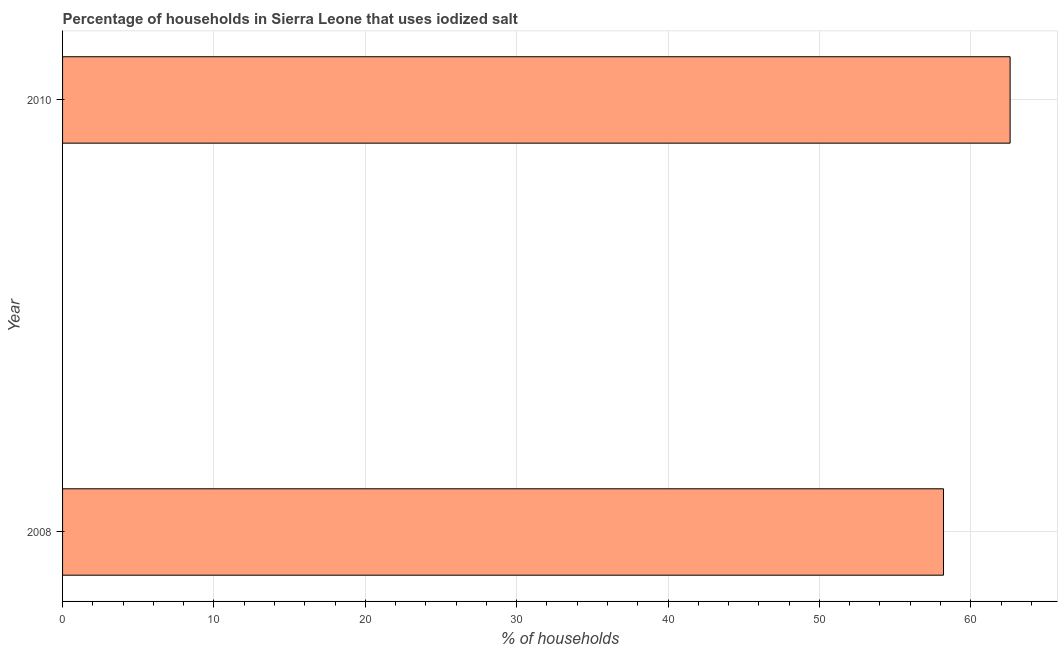What is the title of the graph?
Offer a very short reply. Percentage of households in Sierra Leone that uses iodized salt. What is the label or title of the X-axis?
Your answer should be compact. % of households. What is the label or title of the Y-axis?
Provide a succinct answer. Year. What is the percentage of households where iodized salt is consumed in 2010?
Provide a succinct answer. 62.6. Across all years, what is the maximum percentage of households where iodized salt is consumed?
Your answer should be compact. 62.6. Across all years, what is the minimum percentage of households where iodized salt is consumed?
Offer a terse response. 58.2. In which year was the percentage of households where iodized salt is consumed maximum?
Your answer should be very brief. 2010. In which year was the percentage of households where iodized salt is consumed minimum?
Your answer should be very brief. 2008. What is the sum of the percentage of households where iodized salt is consumed?
Give a very brief answer. 120.8. What is the average percentage of households where iodized salt is consumed per year?
Your answer should be compact. 60.4. What is the median percentage of households where iodized salt is consumed?
Offer a very short reply. 60.4. In how many years, is the percentage of households where iodized salt is consumed greater than 44 %?
Give a very brief answer. 2. Do a majority of the years between 2008 and 2010 (inclusive) have percentage of households where iodized salt is consumed greater than 24 %?
Offer a terse response. Yes. What is the difference between two consecutive major ticks on the X-axis?
Provide a succinct answer. 10. Are the values on the major ticks of X-axis written in scientific E-notation?
Offer a very short reply. No. What is the % of households in 2008?
Offer a terse response. 58.2. What is the % of households in 2010?
Your response must be concise. 62.6. What is the ratio of the % of households in 2008 to that in 2010?
Your answer should be very brief. 0.93. 